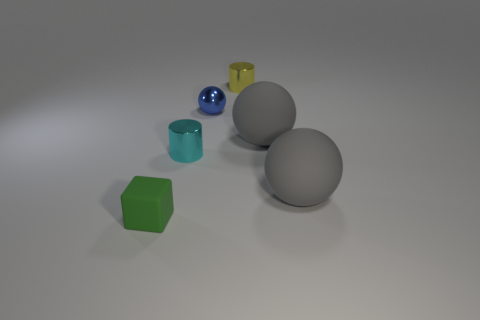Subtract all small blue spheres. How many spheres are left? 2 Add 3 brown cylinders. How many objects exist? 9 Subtract all cubes. How many objects are left? 5 Add 5 big matte blocks. How many big matte blocks exist? 5 Subtract 0 red cylinders. How many objects are left? 6 Subtract all big yellow cubes. Subtract all rubber balls. How many objects are left? 4 Add 4 gray things. How many gray things are left? 6 